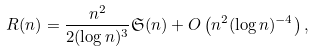Convert formula to latex. <formula><loc_0><loc_0><loc_500><loc_500>R ( n ) = \frac { n ^ { 2 } } { 2 ( \log n ) ^ { 3 } } \mathfrak S ( n ) + O \left ( n ^ { 2 } ( \log n ) ^ { - 4 } \right ) ,</formula> 